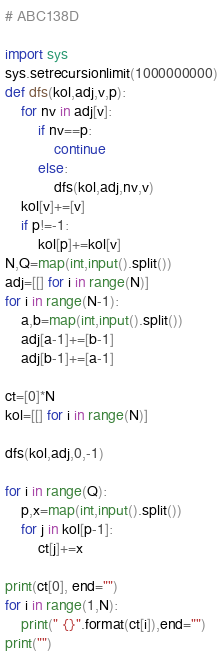Convert code to text. <code><loc_0><loc_0><loc_500><loc_500><_Python_># ABC138D

import sys
sys.setrecursionlimit(1000000000)
def dfs(kol,adj,v,p):
    for nv in adj[v]:
        if nv==p:
            continue
        else:
            dfs(kol,adj,nv,v)
    kol[v]+=[v]
    if p!=-1:
        kol[p]+=kol[v]
N,Q=map(int,input().split())
adj=[[] for i in range(N)]
for i in range(N-1):
    a,b=map(int,input().split())
    adj[a-1]+=[b-1]
    adj[b-1]+=[a-1]
    
ct=[0]*N
kol=[[] for i in range(N)]

dfs(kol,adj,0,-1)

for i in range(Q):
    p,x=map(int,input().split())
    for j in kol[p-1]:
        ct[j]+=x

print(ct[0], end="")
for i in range(1,N):
    print(" {}".format(ct[i]),end="")
print("")</code> 